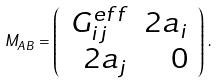<formula> <loc_0><loc_0><loc_500><loc_500>M _ { A B } = \left ( \begin{array} { r r } G ^ { e f f } _ { i j } & 2 a _ { i } \\ 2 a _ { j } & 0 \end{array} \right ) \, .</formula> 